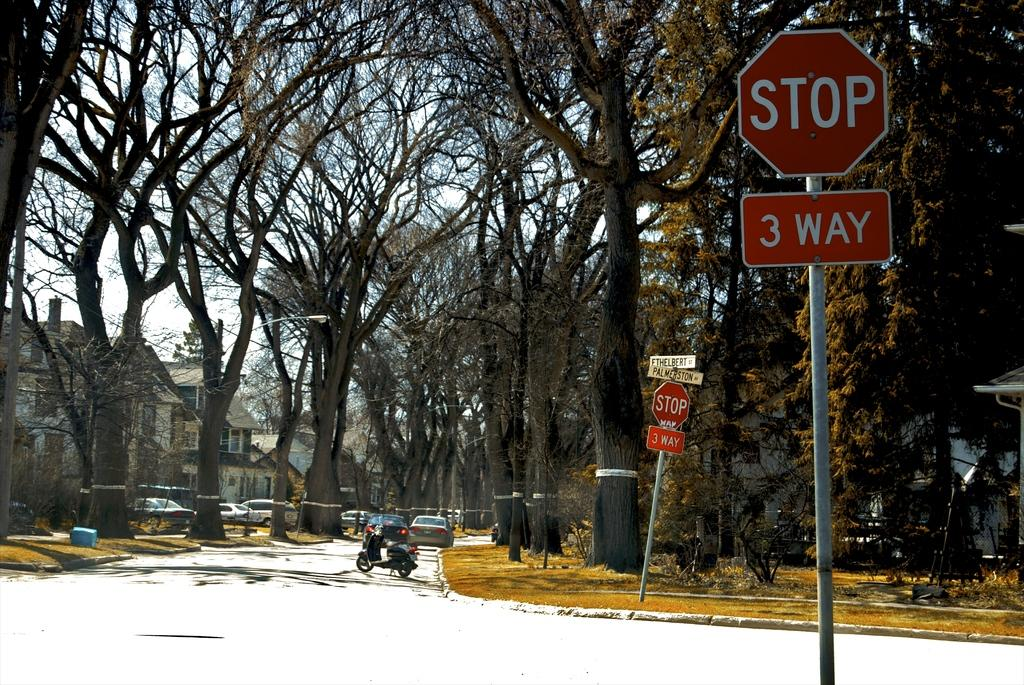<image>
Share a concise interpretation of the image provided. Two three-way stop signs stand at the intersection of Ethelbert and Palmerston with a driver-less scooter in the road past the intersection. 